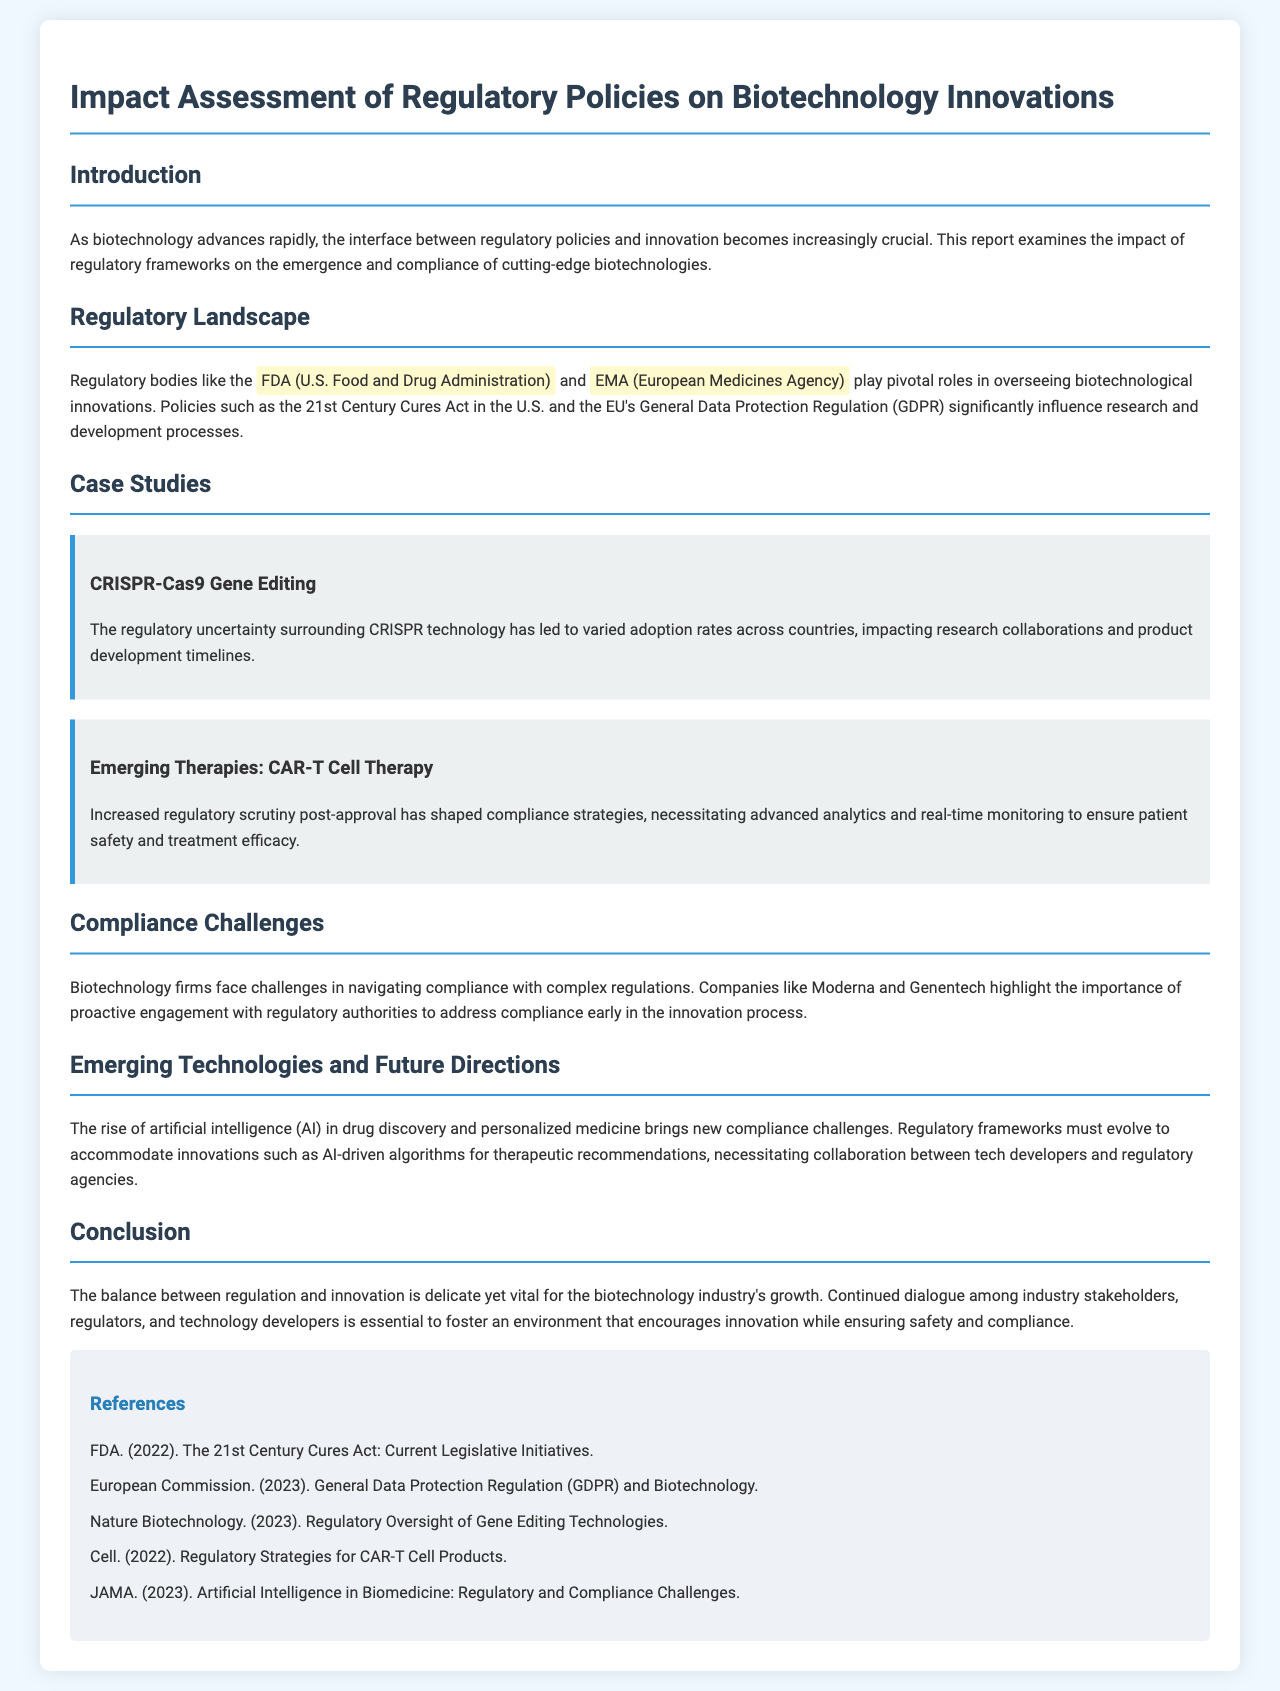What are the two regulatory bodies mentioned? The document outlines the roles of the FDA and EMA in the regulation of biotechnology innovations.
Answer: FDA, EMA What is one significant policy mentioned that influences biotechnology? The report identifies the 21st Century Cures Act in the U.S. as a pivotal regulatory policy affecting biotechnology.
Answer: 21st Century Cures Act What emerging technology is discussed in the context of compliance challenges? The document addresses the rise of artificial intelligence in drug discovery as a key emerging technology.
Answer: Artificial intelligence Which gene editing technology is highlighted in a case study? The report specifically mentions CRISPR-Cas9 as a notable case study in biotechnology.
Answer: CRISPR-Cas9 What therapy is associated with increased regulatory scrutiny post-approval? The case study on CAR-T Cell Therapy discusses the heightened regulatory scrutiny that follows its approval.
Answer: CAR-T Cell Therapy What aspect of biotechnology does the report emphasize as vital for industry growth? The document suggests that the balance between regulation and innovation is crucial for the biotechnology sector's development.
Answer: Balance between regulation and innovation What method do biotechnology firms need for successful compliance? The report indicates that proactive engagement with regulatory authorities is necessary for compliance.
Answer: Proactive engagement How many references are listed at the end of the report? The document provides a total of five references that support its content and findings.
Answer: Five 